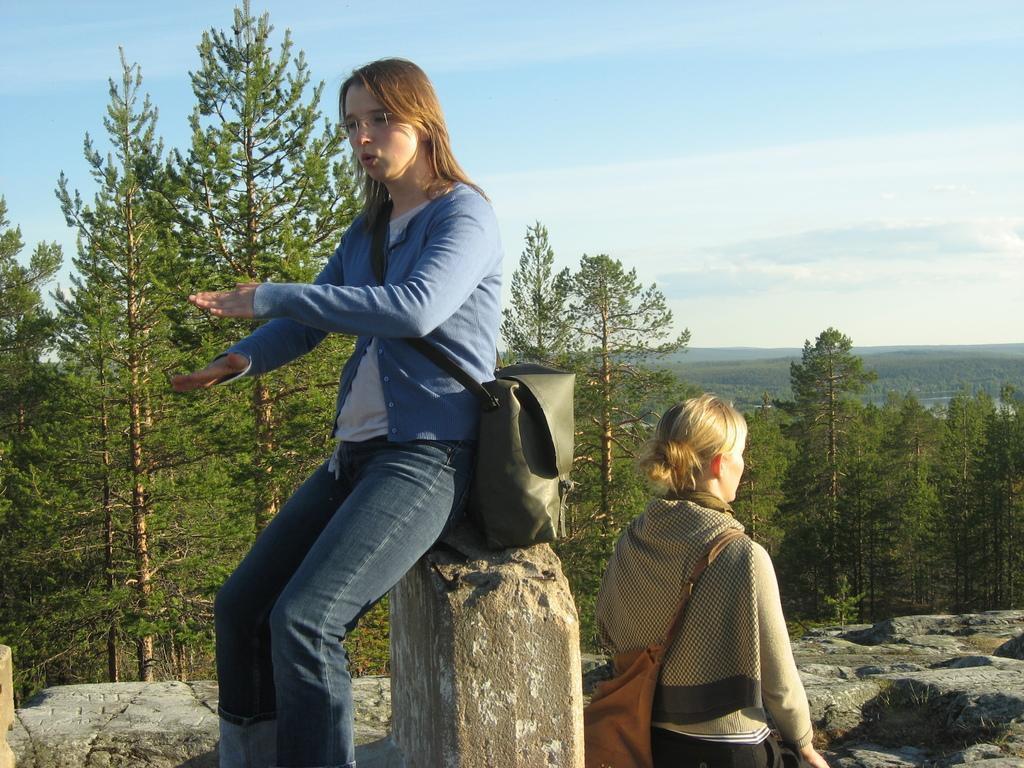Describe this image in one or two sentences. In this image I can see two women in the front where one is sitting and one is standing. I can also see both of them are carrying bags. In the background I can see number of trees, clouds and the sky. 